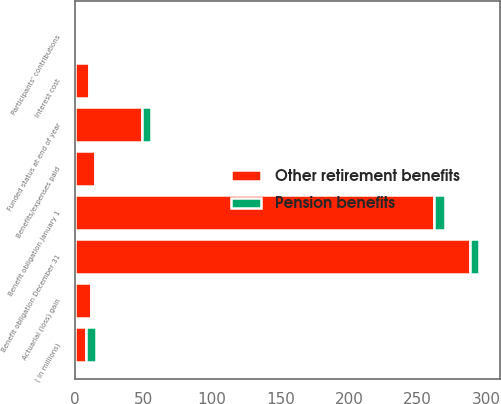Convert chart to OTSL. <chart><loc_0><loc_0><loc_500><loc_500><stacked_bar_chart><ecel><fcel>( in millions)<fcel>Benefit obligation January 1<fcel>Interest cost<fcel>Participants' contributions<fcel>Actuarial (loss) gain<fcel>Benefits/expenses paid<fcel>Benefit obligation December 31<fcel>Funded status at end of year<nl><fcel>Other retirement benefits<fcel>7.55<fcel>262.2<fcel>9.8<fcel>0.7<fcel>11.8<fcel>14.2<fcel>288<fcel>48.5<nl><fcel>Pension benefits<fcel>7.55<fcel>8<fcel>0.3<fcel>0.5<fcel>1.2<fcel>0.5<fcel>7.1<fcel>7.1<nl></chart> 